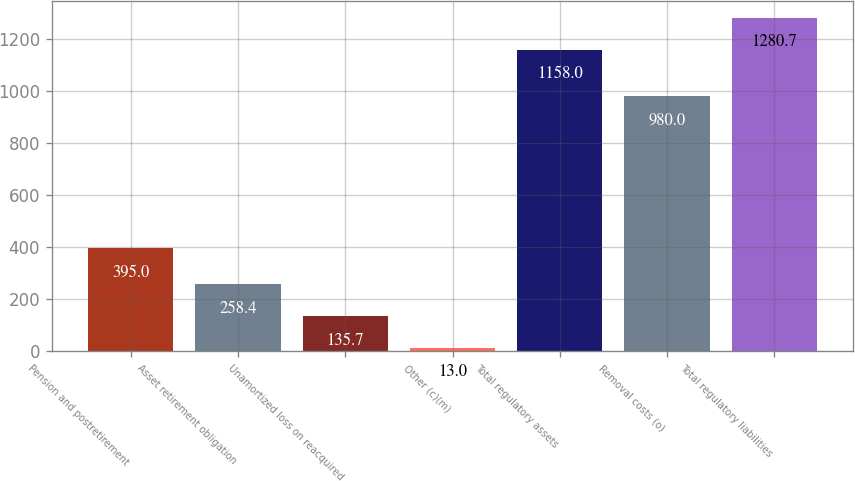Convert chart. <chart><loc_0><loc_0><loc_500><loc_500><bar_chart><fcel>Pension and postretirement<fcel>Asset retirement obligation<fcel>Unamortized loss on reacquired<fcel>Other (c)(m)<fcel>Total regulatory assets<fcel>Removal costs (o)<fcel>Total regulatory liabilities<nl><fcel>395<fcel>258.4<fcel>135.7<fcel>13<fcel>1158<fcel>980<fcel>1280.7<nl></chart> 